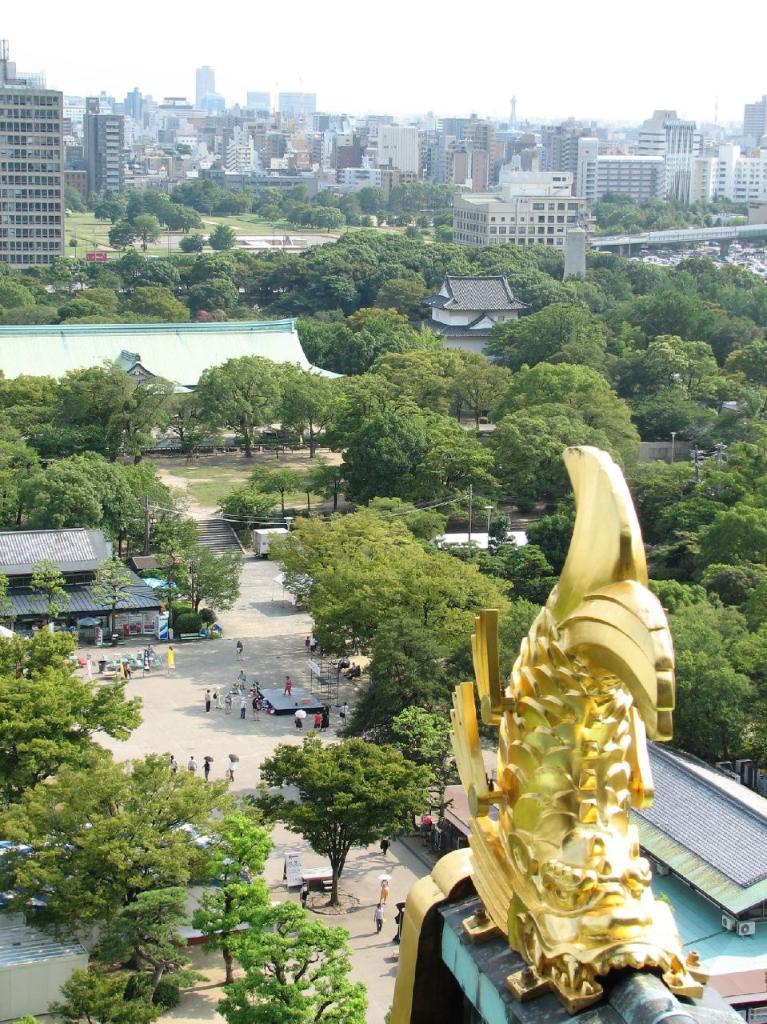What type of structures can be seen in the image? There are buildings in the image. What natural elements are present in the image? There are trees in the image. Who or what else can be seen in the image? There are people and a sculpture in the image. How would you describe the weather in the image? The sky is cloudy in the image. Can you hear anyone coughing or crying in the image? There is no sound present in the image, so it is impossible to determine if anyone is coughing or crying. What type of pot is being used by the people in the image? There is no pot present in the image. 